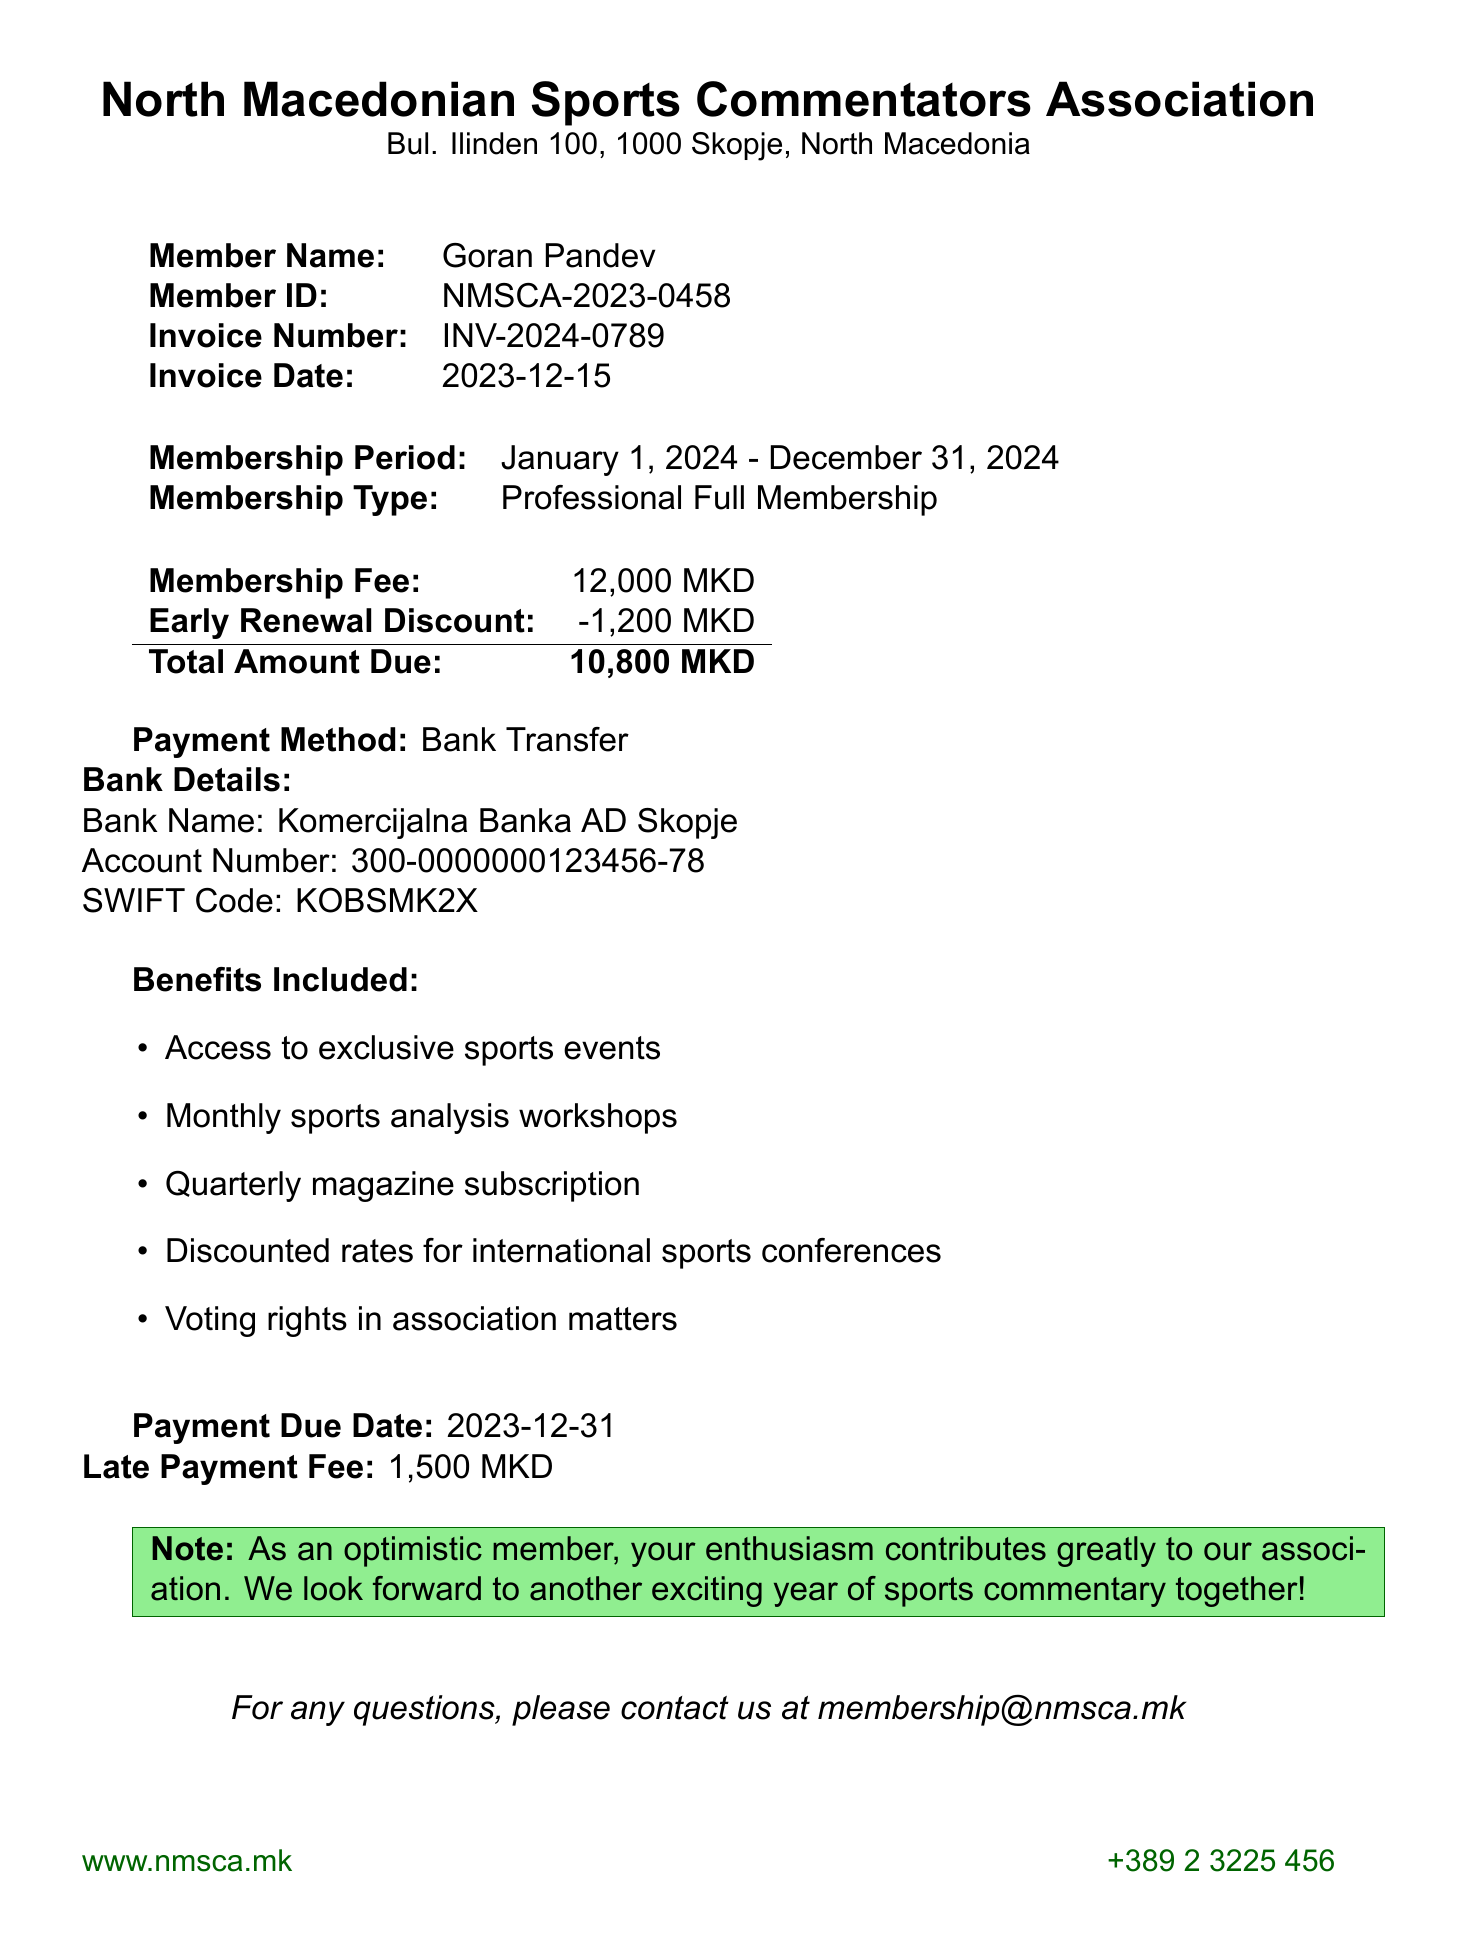What is the membership fee? The membership fee is stated in the document as part of the financial details.
Answer: 12,000 MKD What is the amount due after the early renewal discount? The total amount due considers the membership fee and the applied early renewal discount.
Answer: 10,800 MKD When is the payment due date? The payment due date is specified directly in the document.
Answer: 2023-12-31 What are the voting rights related to? Voting rights pertain to participation in the association's decision-making, highlighted in the benefits included section.
Answer: Association matters Who is the invoice addressed to? The member name mentioned in the document provides this information.
Answer: Goran Pandev What is the early renewal discount amount? The discount for early renewal is explicitly listed in the invoice details.
Answer: 1,200 MKD What type of membership is being renewed? The membership type describes the category of membership and is found in the relevant section of the document.
Answer: Professional Full Membership What method of payment is accepted? The payment method is clearly identified in the financial transaction section of the document.
Answer: Bank Transfer What benefits do members receive? The benefits listed provide an overview of advantages for members in the association.
Answer: Access to exclusive sports events, Monthly sports analysis workshops, Quarterly magazine subscription, Discounted rates for international sports conferences, Voting rights in association matters 